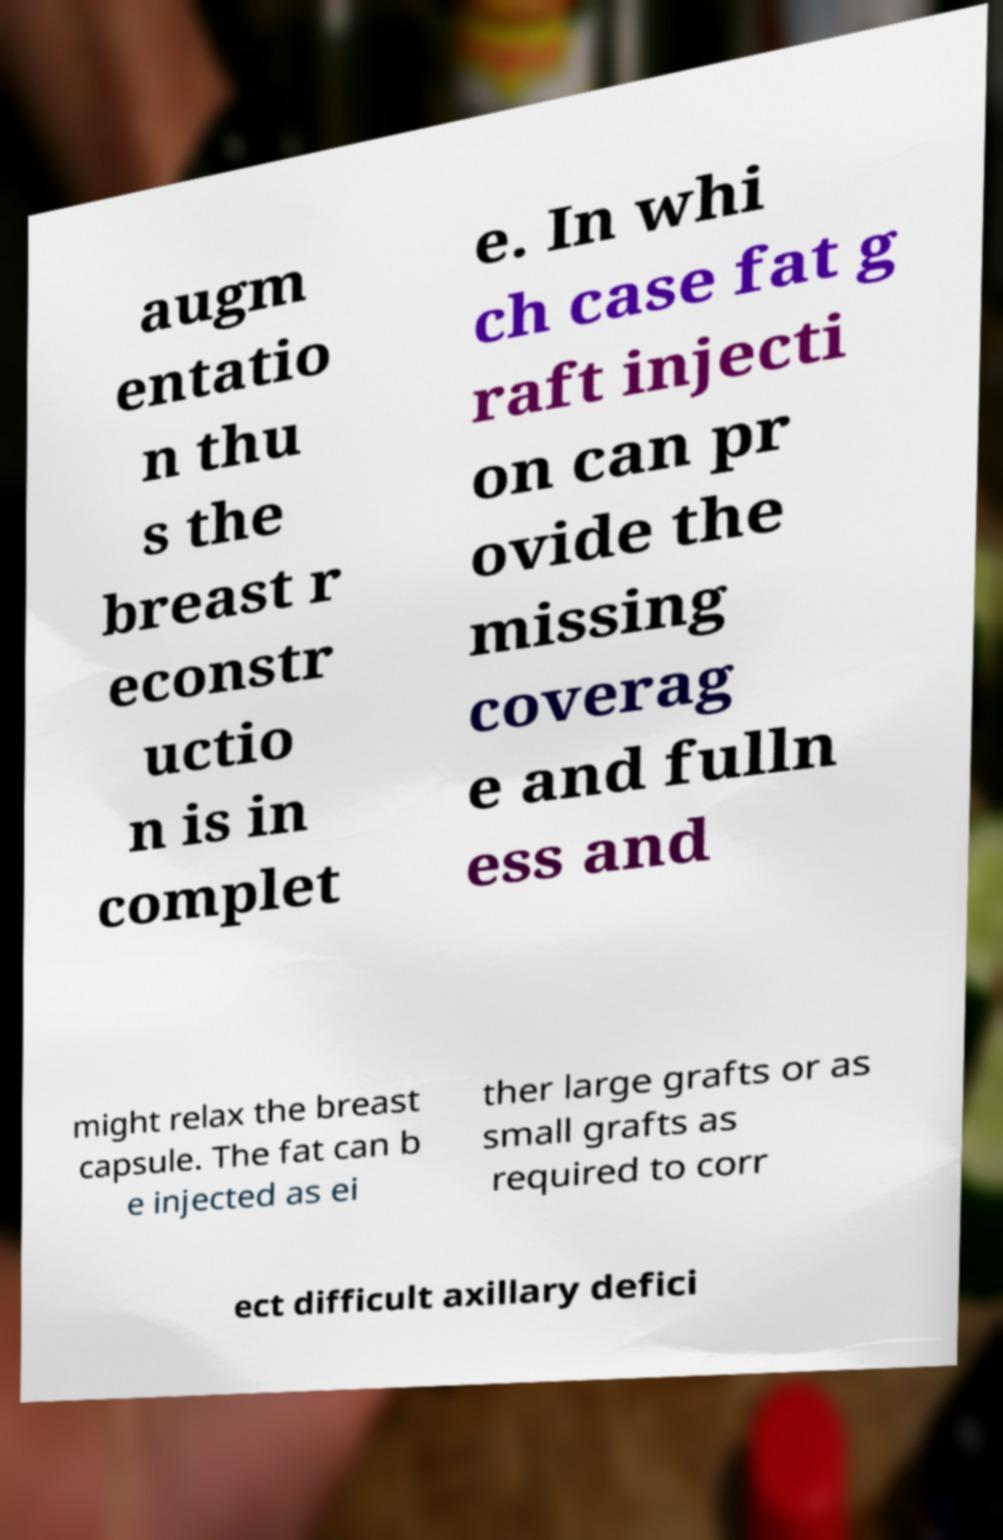For documentation purposes, I need the text within this image transcribed. Could you provide that? augm entatio n thu s the breast r econstr uctio n is in complet e. In whi ch case fat g raft injecti on can pr ovide the missing coverag e and fulln ess and might relax the breast capsule. The fat can b e injected as ei ther large grafts or as small grafts as required to corr ect difficult axillary defici 